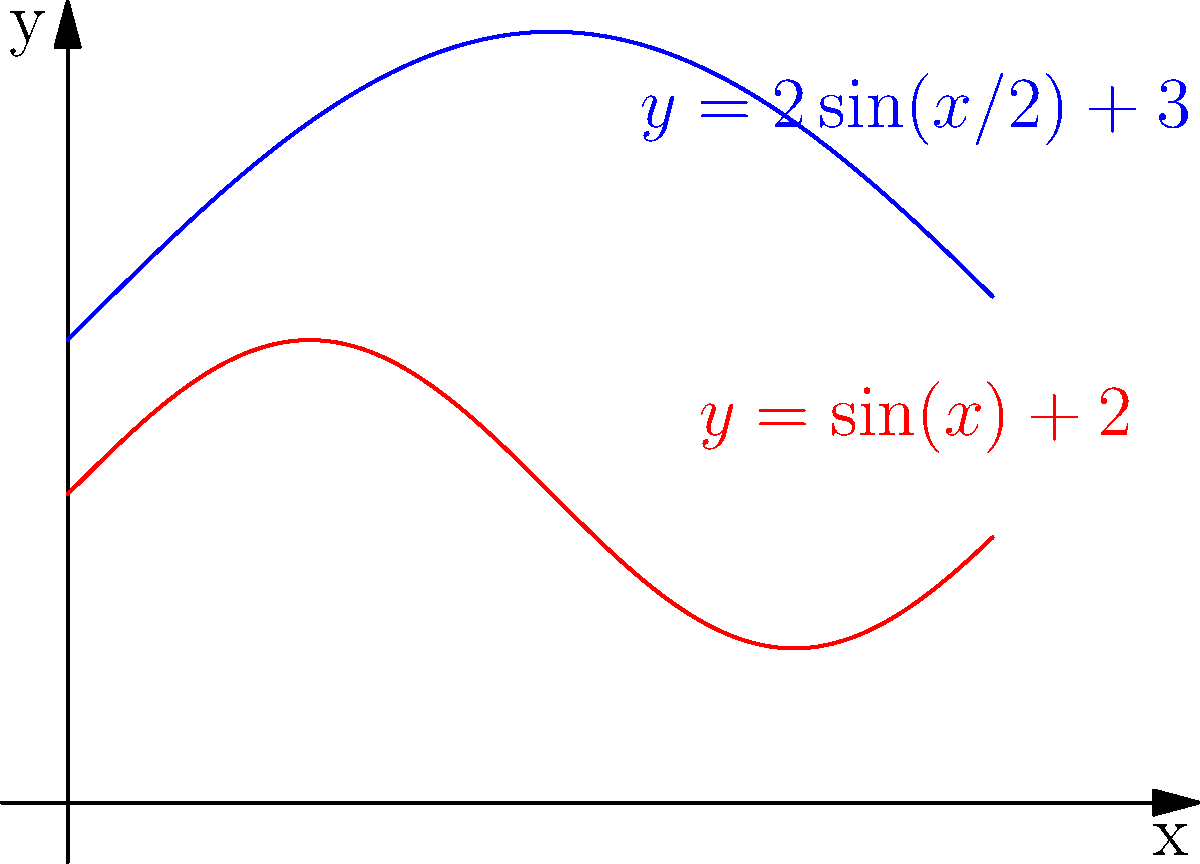During a laparoscopic procedure, you need to make an irregularly shaped incision. The upper boundary of the incision is described by the function $f(x) = 2\sin(x/2) + 3$, and the lower boundary is described by $g(x) = \sin(x) + 2$, where $x$ is measured in centimeters. Calculate the area of the incision between $x = 0$ and $x = 6$ cm. To find the area between two curves, we need to integrate the difference between the upper and lower functions over the given interval. Here's how we solve this problem:

1) The area is given by the definite integral:
   $$A = \int_0^6 [f(x) - g(x)] dx$$

2) Substituting the functions:
   $$A = \int_0^6 [(2\sin(x/2) + 3) - (\sin(x) + 2)] dx$$

3) Simplify:
   $$A = \int_0^6 [2\sin(x/2) - \sin(x) + 1] dx$$

4) We can't directly integrate this, so we need to use numerical integration methods or a calculator. Using a calculator or computer algebra system, we get:

   $$A \approx 5.2915$$ cm²

5) In a surgical context, we typically round to two decimal places for practical purposes.

Therefore, the area of the incision is approximately 5.29 cm².
Answer: 5.29 cm² 